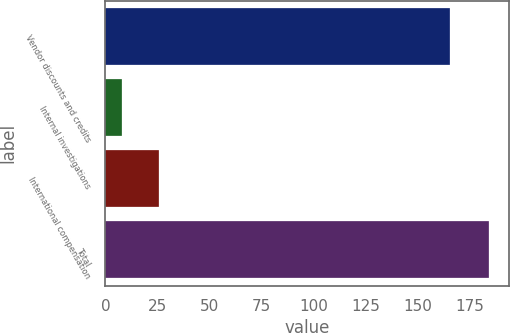Convert chart. <chart><loc_0><loc_0><loc_500><loc_500><bar_chart><fcel>Vendor discounts and credits<fcel>Internal investigations<fcel>International compensation<fcel>Total<nl><fcel>165.5<fcel>8.2<fcel>25.84<fcel>184.6<nl></chart> 